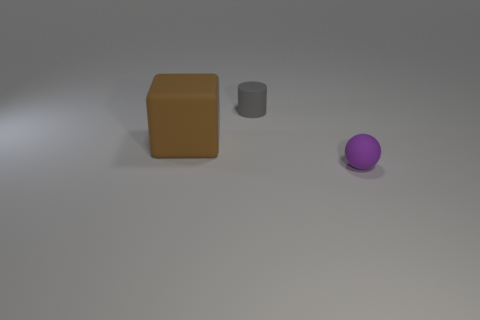Add 1 purple matte spheres. How many objects exist? 4 Subtract all blocks. How many objects are left? 2 Add 3 large red rubber cubes. How many large red rubber cubes exist? 3 Subtract 0 brown spheres. How many objects are left? 3 Subtract all large brown cylinders. Subtract all gray rubber objects. How many objects are left? 2 Add 3 tiny cylinders. How many tiny cylinders are left? 4 